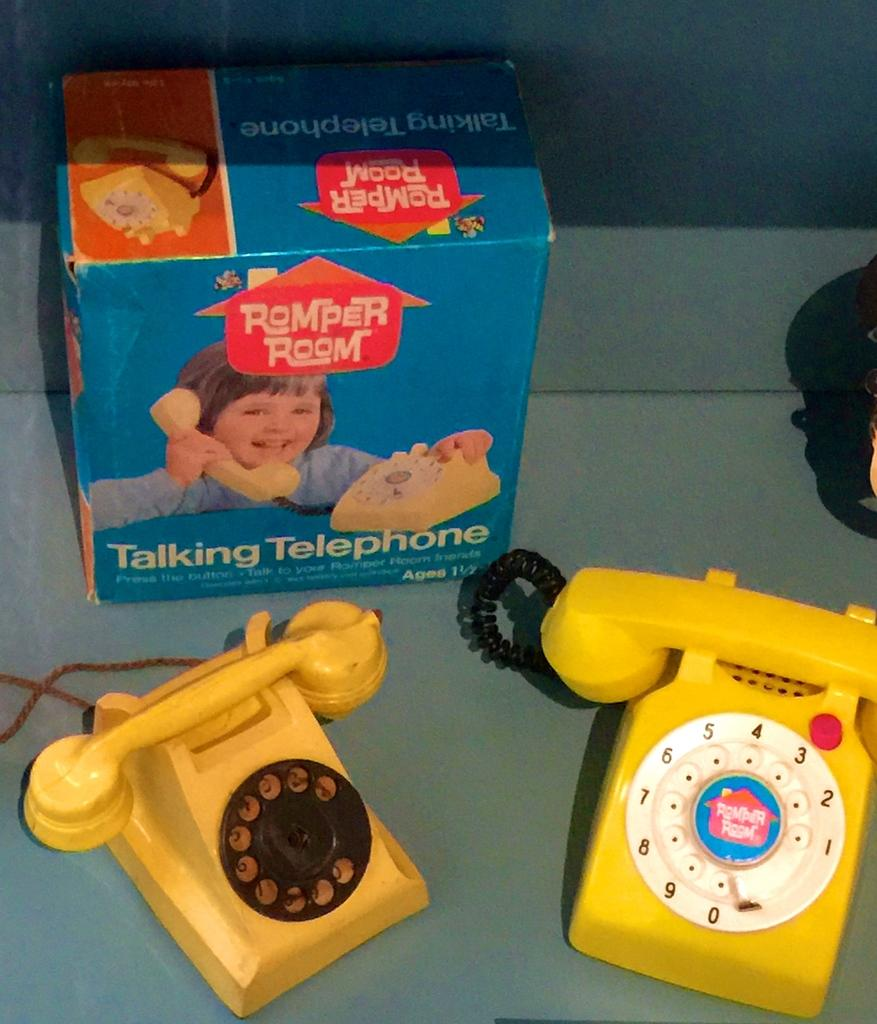What objects are located at the bottom of the image? There are telephones at the bottom of the image. What is at the top of the image? There is a box with images at the top of the image. What type of body is visible in the image? There is no body present in the image; it features telephones at the bottom and a box with images at the top. Can you tell me how much sand is in the image? There is no sand present in the image. 